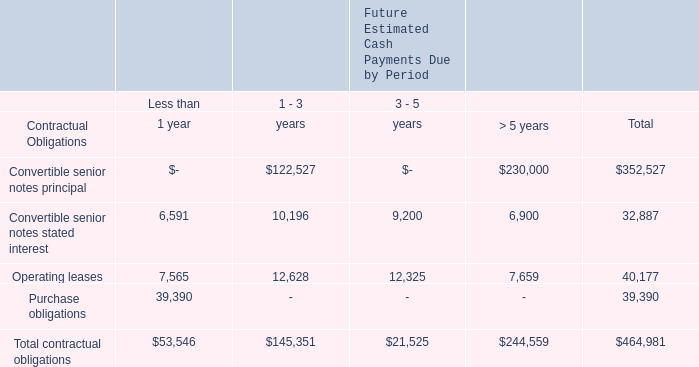Contractual Obligations
Following is a summary of our contractual cash obligations as of February 28, 2019 (in thousands):
Purchase obligations consist primarily of inventory purchase commitments.
What does purchase obligations consist primarily of? Inventory purchase commitments. What were the total Operating Leases? 
Answer scale should be: thousand. 40,177. What were the total Purchase Obligations?
Answer scale should be: thousand. 39,390. How much do the top 3 contractual obligation terms add up to?
Answer scale should be: thousand. (352,527+40,177+39,390)
Answer: 432094. What are the Operating Leases as a percentage of the total contractual obligations? 
Answer scale should be: percent. (40,177/464,981)
Answer: 8.64. What are the Purchase Obligations as a percentage of the total contractual obligations? 
Answer scale should be: percent. (39,390/464,981)
Answer: 8.47. 